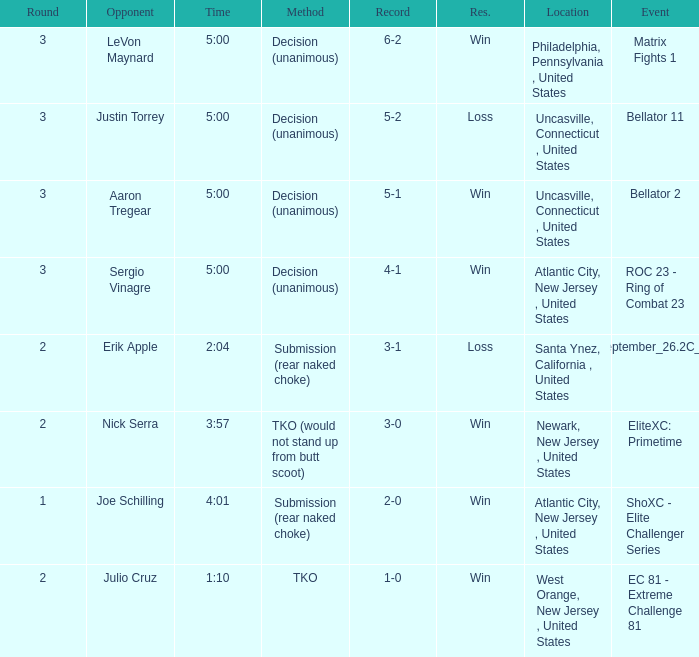Who was the opponent when there was a TKO method? Julio Cruz. 